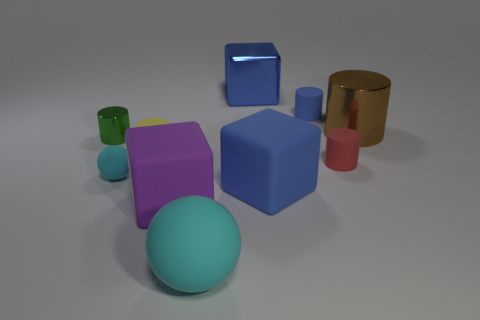Subtract 2 cylinders. How many cylinders are left? 3 Subtract all blue cylinders. How many cylinders are left? 4 Subtract all red matte cylinders. How many cylinders are left? 4 Subtract all green cylinders. Subtract all yellow cubes. How many cylinders are left? 4 Subtract all spheres. How many objects are left? 8 Add 4 small green metallic cylinders. How many small green metallic cylinders are left? 5 Add 1 small red rubber balls. How many small red rubber balls exist? 1 Subtract 1 blue cubes. How many objects are left? 9 Subtract all big blue matte things. Subtract all green cylinders. How many objects are left? 8 